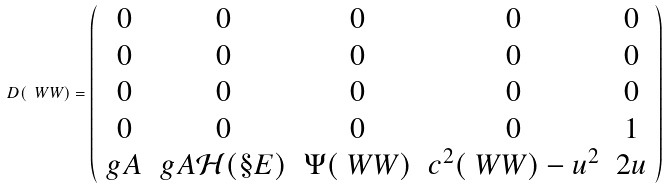Convert formula to latex. <formula><loc_0><loc_0><loc_500><loc_500>D ( \ W W ) = \left ( \begin{array} { c c c c c } 0 & 0 & 0 & 0 & 0 \\ 0 & 0 & 0 & 0 & 0 \\ 0 & 0 & 0 & 0 & 0 \\ 0 & 0 & 0 & 0 & 1 \\ g A & g A \mathcal { H } ( \S E ) & \Psi ( \ W W ) & c ^ { 2 } ( \ W W ) - u ^ { 2 } & 2 u \\ \end{array} \right )</formula> 